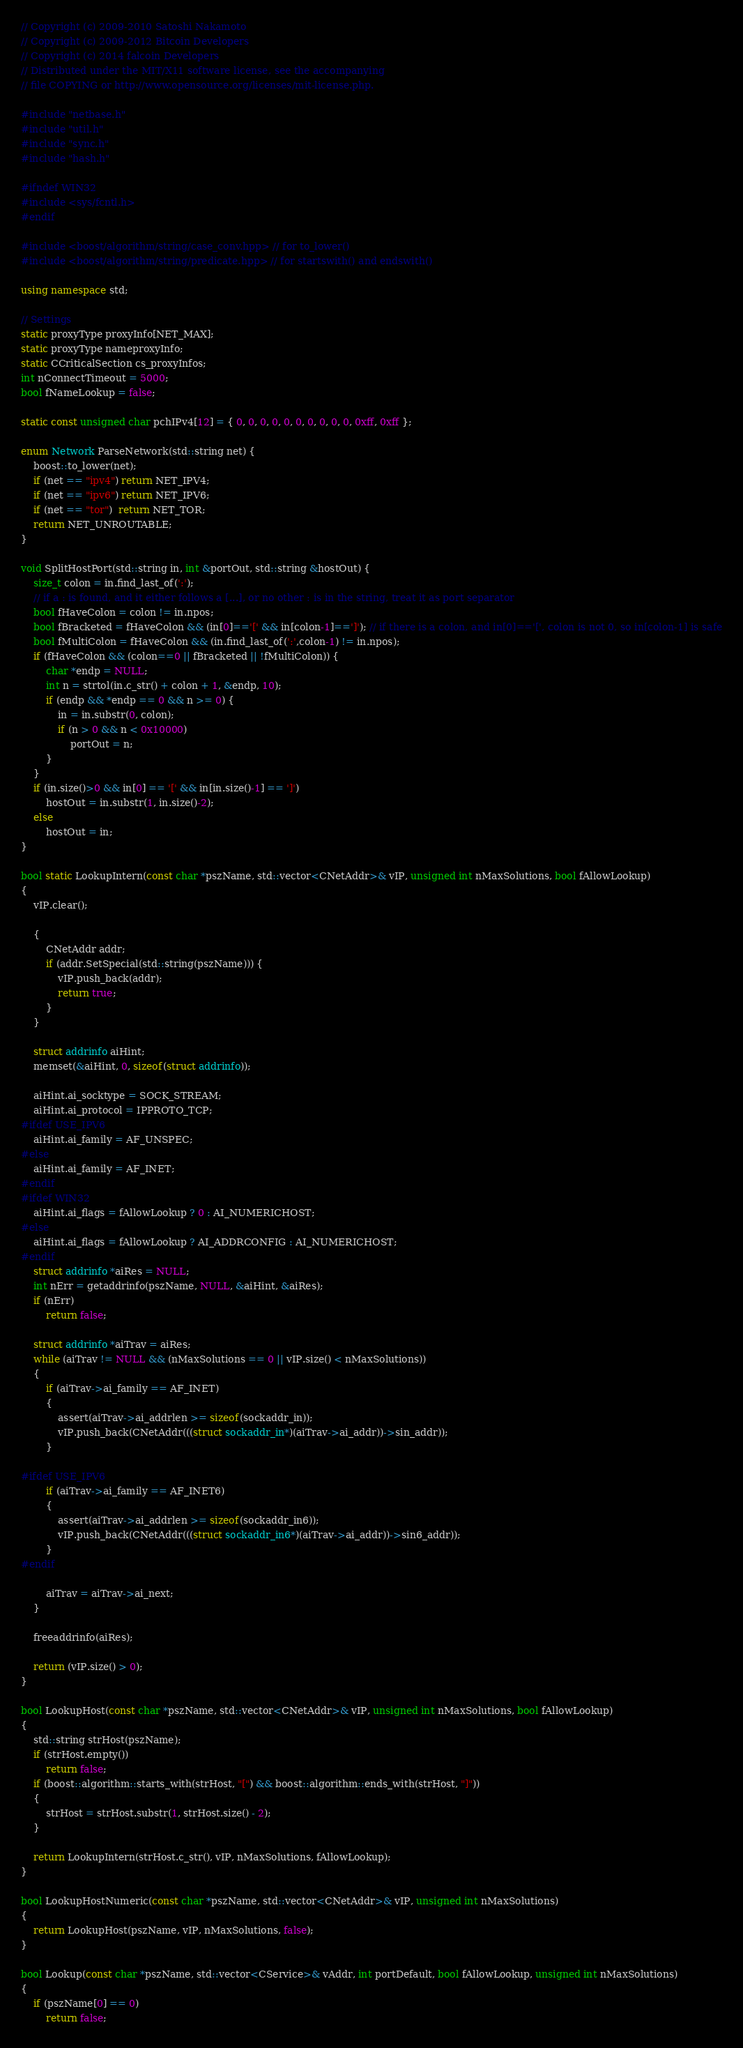Convert code to text. <code><loc_0><loc_0><loc_500><loc_500><_C++_>// Copyright (c) 2009-2010 Satoshi Nakamoto
// Copyright (c) 2009-2012 Bitcoin Developers
// Copyright (c) 2014 falcoin Developers
// Distributed under the MIT/X11 software license, see the accompanying
// file COPYING or http://www.opensource.org/licenses/mit-license.php.

#include "netbase.h"
#include "util.h"
#include "sync.h"
#include "hash.h"

#ifndef WIN32
#include <sys/fcntl.h>
#endif

#include <boost/algorithm/string/case_conv.hpp> // for to_lower()
#include <boost/algorithm/string/predicate.hpp> // for startswith() and endswith()

using namespace std;

// Settings
static proxyType proxyInfo[NET_MAX];
static proxyType nameproxyInfo;
static CCriticalSection cs_proxyInfos;
int nConnectTimeout = 5000;
bool fNameLookup = false;

static const unsigned char pchIPv4[12] = { 0, 0, 0, 0, 0, 0, 0, 0, 0, 0, 0xff, 0xff };

enum Network ParseNetwork(std::string net) {
    boost::to_lower(net);
    if (net == "ipv4") return NET_IPV4;
    if (net == "ipv6") return NET_IPV6;
    if (net == "tor")  return NET_TOR;
    return NET_UNROUTABLE;
}

void SplitHostPort(std::string in, int &portOut, std::string &hostOut) {
    size_t colon = in.find_last_of(':');
    // if a : is found, and it either follows a [...], or no other : is in the string, treat it as port separator
    bool fHaveColon = colon != in.npos;
    bool fBracketed = fHaveColon && (in[0]=='[' && in[colon-1]==']'); // if there is a colon, and in[0]=='[', colon is not 0, so in[colon-1] is safe
    bool fMultiColon = fHaveColon && (in.find_last_of(':',colon-1) != in.npos);
    if (fHaveColon && (colon==0 || fBracketed || !fMultiColon)) {
        char *endp = NULL;
        int n = strtol(in.c_str() + colon + 1, &endp, 10);
        if (endp && *endp == 0 && n >= 0) {
            in = in.substr(0, colon);
            if (n > 0 && n < 0x10000)
                portOut = n;
        }
    }
    if (in.size()>0 && in[0] == '[' && in[in.size()-1] == ']')
        hostOut = in.substr(1, in.size()-2);
    else
        hostOut = in;
}

bool static LookupIntern(const char *pszName, std::vector<CNetAddr>& vIP, unsigned int nMaxSolutions, bool fAllowLookup)
{
    vIP.clear();

    {
        CNetAddr addr;
        if (addr.SetSpecial(std::string(pszName))) {
            vIP.push_back(addr);
            return true;
        }
    }

    struct addrinfo aiHint;
    memset(&aiHint, 0, sizeof(struct addrinfo));

    aiHint.ai_socktype = SOCK_STREAM;
    aiHint.ai_protocol = IPPROTO_TCP;
#ifdef USE_IPV6
    aiHint.ai_family = AF_UNSPEC;
#else
    aiHint.ai_family = AF_INET;
#endif
#ifdef WIN32
    aiHint.ai_flags = fAllowLookup ? 0 : AI_NUMERICHOST;
#else
    aiHint.ai_flags = fAllowLookup ? AI_ADDRCONFIG : AI_NUMERICHOST;
#endif
    struct addrinfo *aiRes = NULL;
    int nErr = getaddrinfo(pszName, NULL, &aiHint, &aiRes);
    if (nErr)
        return false;

    struct addrinfo *aiTrav = aiRes;
    while (aiTrav != NULL && (nMaxSolutions == 0 || vIP.size() < nMaxSolutions))
    {
        if (aiTrav->ai_family == AF_INET)
        {
            assert(aiTrav->ai_addrlen >= sizeof(sockaddr_in));
            vIP.push_back(CNetAddr(((struct sockaddr_in*)(aiTrav->ai_addr))->sin_addr));
        }

#ifdef USE_IPV6
        if (aiTrav->ai_family == AF_INET6)
        {
            assert(aiTrav->ai_addrlen >= sizeof(sockaddr_in6));
            vIP.push_back(CNetAddr(((struct sockaddr_in6*)(aiTrav->ai_addr))->sin6_addr));
        }
#endif

        aiTrav = aiTrav->ai_next;
    }

    freeaddrinfo(aiRes);

    return (vIP.size() > 0);
}

bool LookupHost(const char *pszName, std::vector<CNetAddr>& vIP, unsigned int nMaxSolutions, bool fAllowLookup)
{
    std::string strHost(pszName);
    if (strHost.empty())
        return false;
    if (boost::algorithm::starts_with(strHost, "[") && boost::algorithm::ends_with(strHost, "]"))
    {
        strHost = strHost.substr(1, strHost.size() - 2);
    }

    return LookupIntern(strHost.c_str(), vIP, nMaxSolutions, fAllowLookup);
}

bool LookupHostNumeric(const char *pszName, std::vector<CNetAddr>& vIP, unsigned int nMaxSolutions)
{
    return LookupHost(pszName, vIP, nMaxSolutions, false);
}

bool Lookup(const char *pszName, std::vector<CService>& vAddr, int portDefault, bool fAllowLookup, unsigned int nMaxSolutions)
{
    if (pszName[0] == 0)
        return false;</code> 